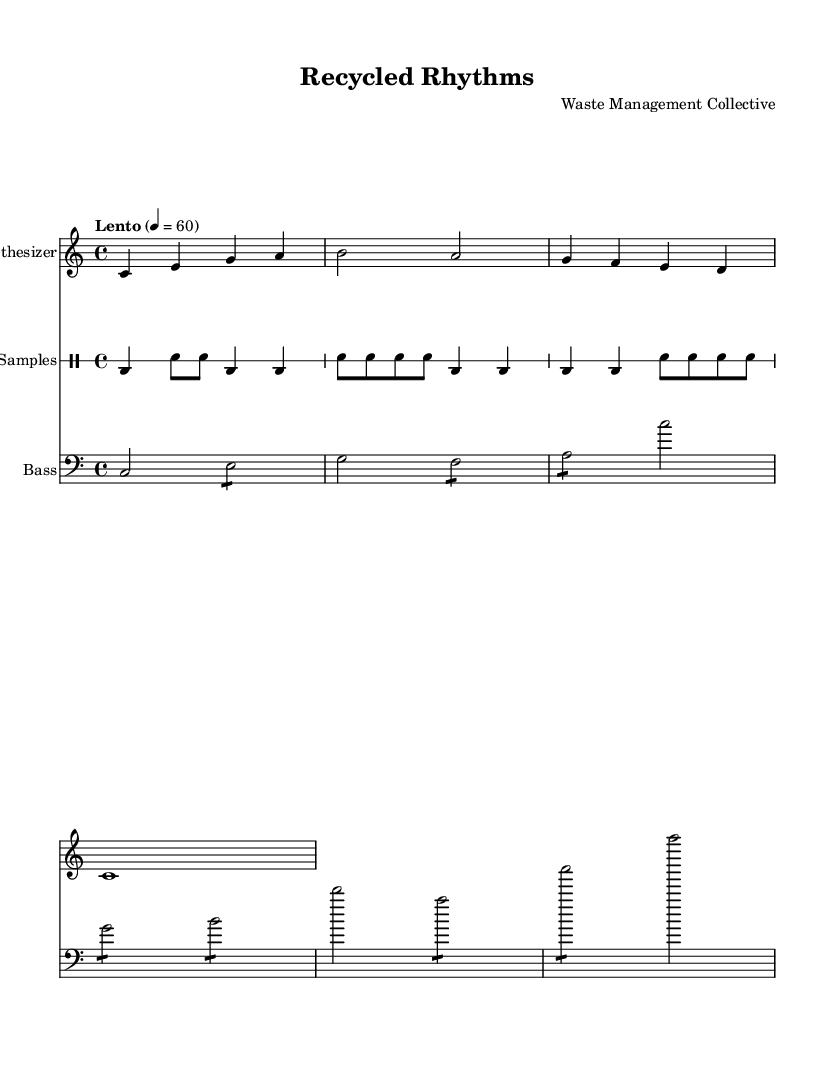What is the key signature of this music? The key signature is C major, indicated at the beginning of the score. C major has no sharps or flats.
Answer: C major What is the time signature of this music? The time signature is 4/4, which can be found after the key signature in the global section of the score.
Answer: 4/4 What is the tempo marking of the piece? The tempo marking is "Lento," which indicates a slow pace. It is noted in the global settings as well.
Answer: Lento How many measures are in the synthesizer part? The synthesizer part has four measures, as indicated by the four distinct phrases separated by bar lines.
Answer: 4 What is the rhythmic pattern of the drum samples? The drum samples consist of a pattern that alternates between bass drum and snare with a specific sequence across three measures. The counting reveals a distinctive layering that represents the waste sorting sound motifs.
Answer: Bass drum and snare What is the highest pitch note in the bass line? The highest pitch note in the bass line is C', as seen in the last measure where the bass part ascends to this note.
Answer: C' What unique element identifies this music as Experimental? The use of ambient sounds and unconventional rhythmic patterns derived from sounds of waste sorting facilities gives this music its experimental identity.
Answer: Ambient sounds 